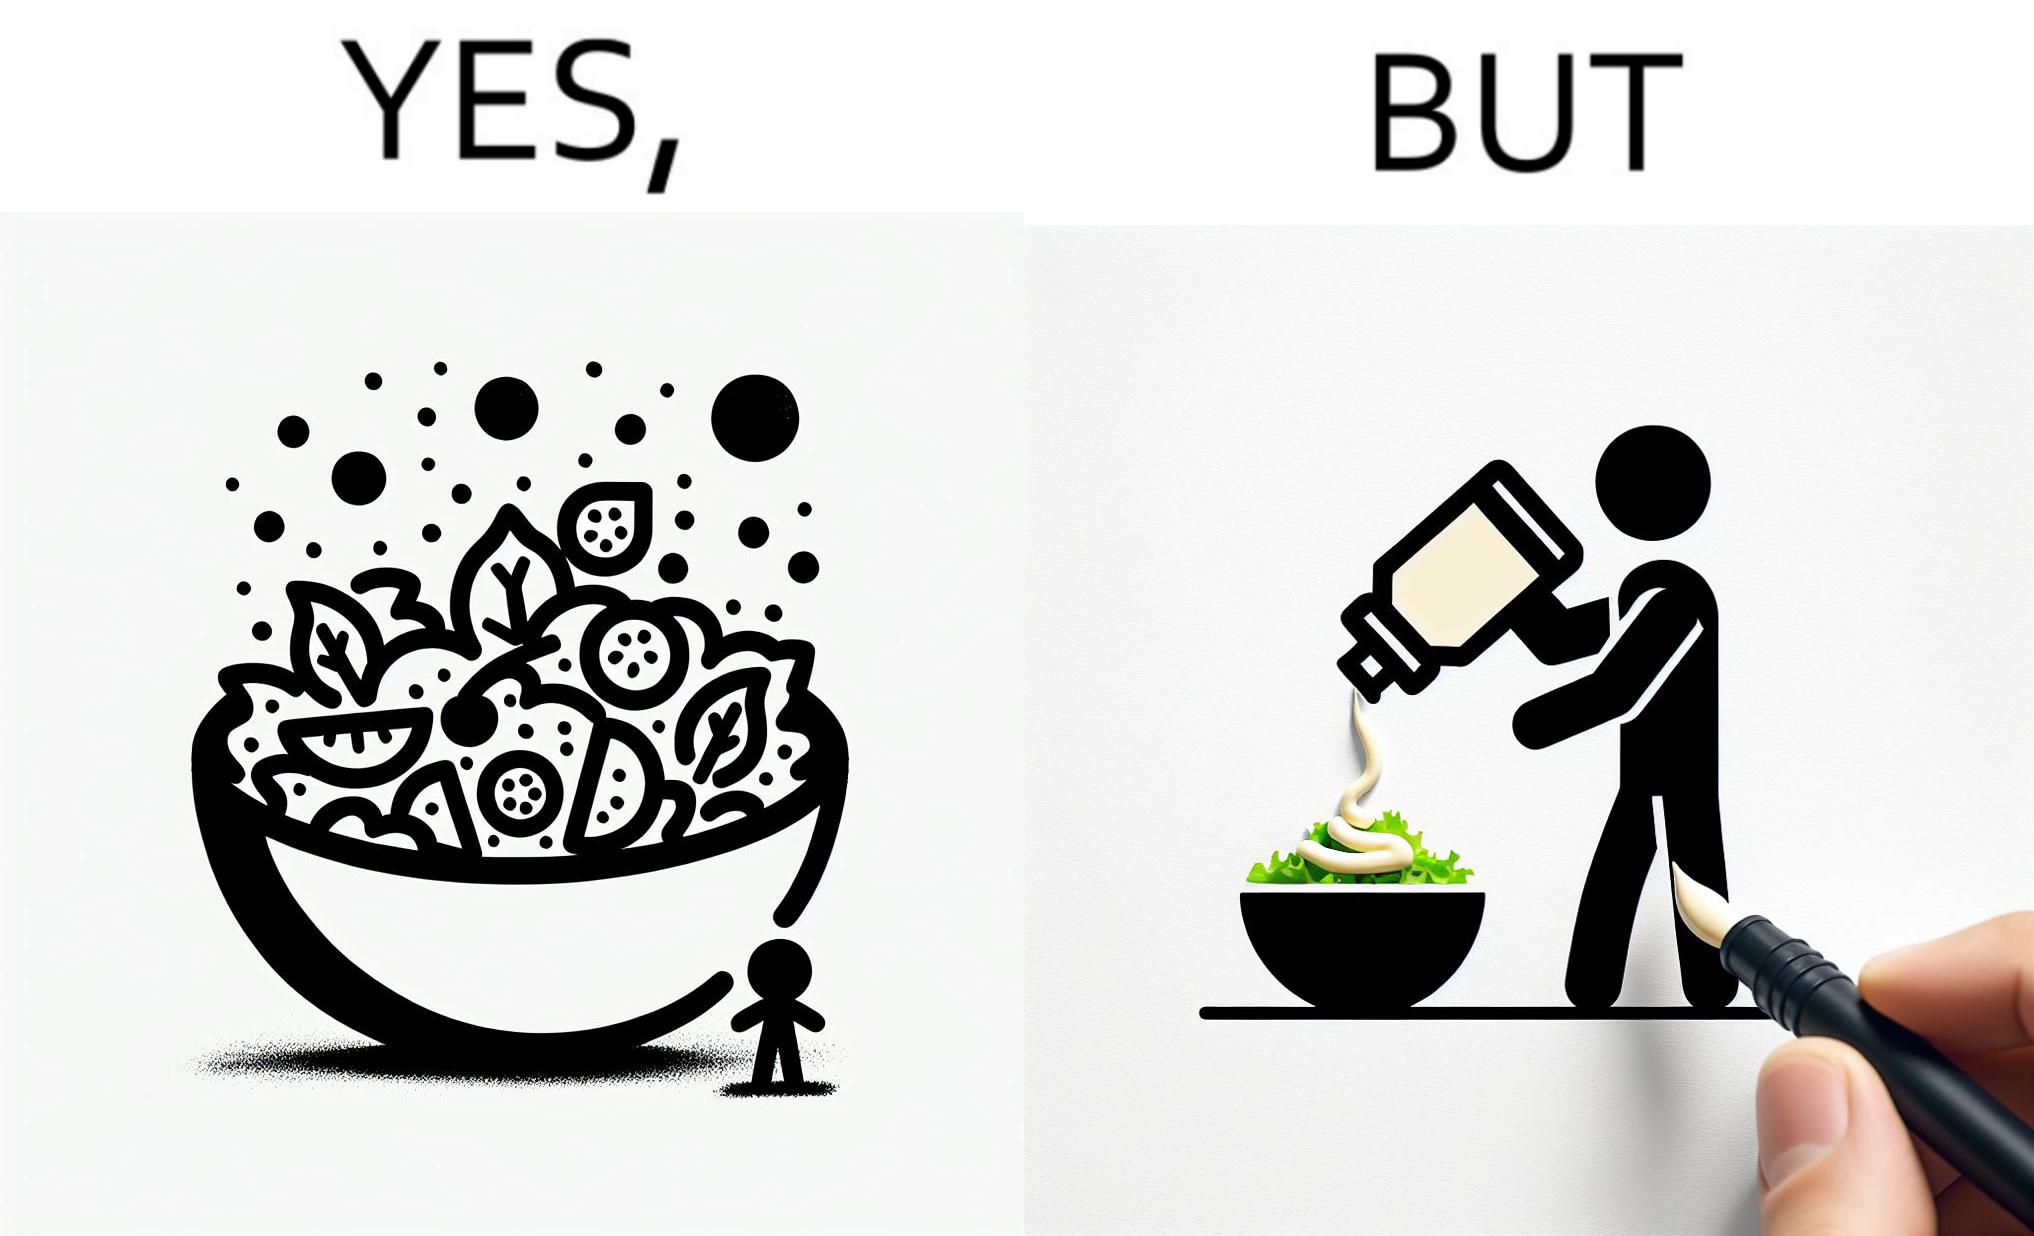Explain why this image is satirical. The image is ironical, as salad in a bowl by itself is very healthy. However, when people have it with Mayonnaise sauce to improve the taste, it is not healthy anymore, and defeats the point of having nutrient-rich salad altogether. 